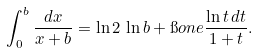Convert formula to latex. <formula><loc_0><loc_0><loc_500><loc_500>\int _ { 0 } ^ { b } \frac { d x } { x + b } = \ln 2 \, \ln b + \i o n e \frac { \ln t \, d t } { 1 + t } .</formula> 